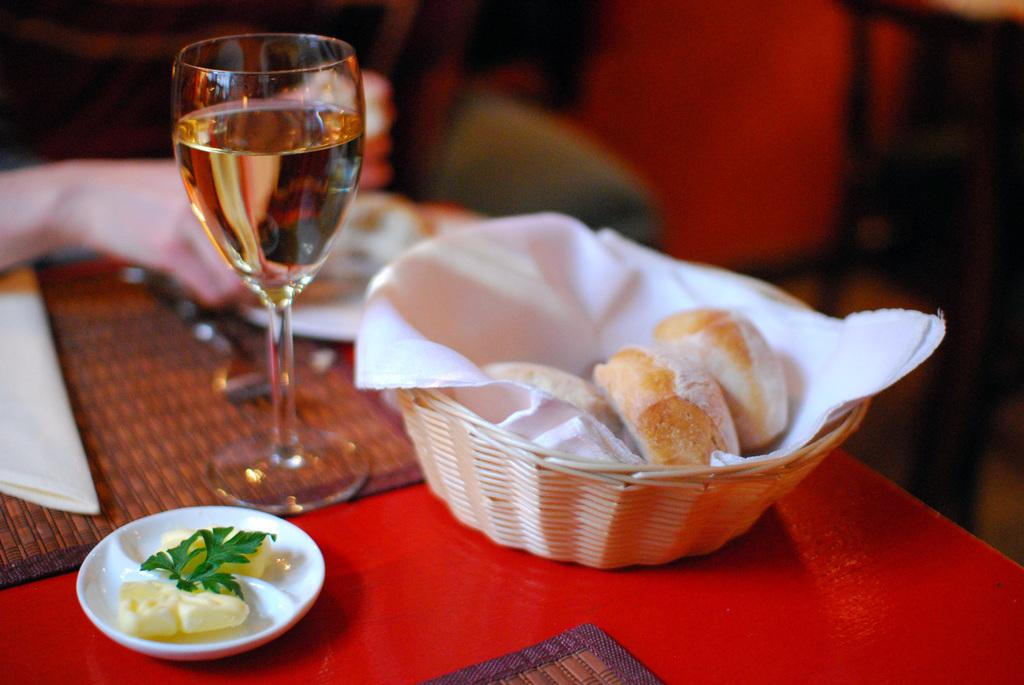What types of food items can be seen in the image? There are food items in the image, but their specific types are not mentioned. What is the purpose of the basket in the image? The purpose of the basket in the image is not specified. What is the plate used for in the image? The plate is used for holding food in the image. What is the wine glass containing in the image? The wine glass contains wine in the image. What is the napkin used for in the image? The napkin is used for wiping or cleaning in the image. What are the dining placemats used for in the image? The dining placemats are used to protect the table and provide a decorative touch in the image. Can you describe the background of the image? The background of the image is blurred. Can you see a kitty playing with the wine glass in the image? There is no kitty present in the image, and therefore no such activity can be observed. Is there a deer grazing on the dining placemats in the image? There is no deer present in the image, and therefore no such activity can be observed. 